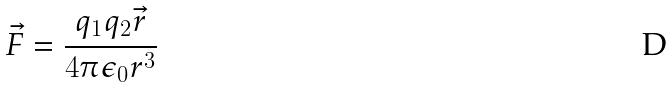Convert formula to latex. <formula><loc_0><loc_0><loc_500><loc_500>\vec { F } = \frac { q _ { 1 } q _ { 2 } \vec { r } } { 4 \pi \epsilon _ { 0 } r ^ { 3 } }</formula> 